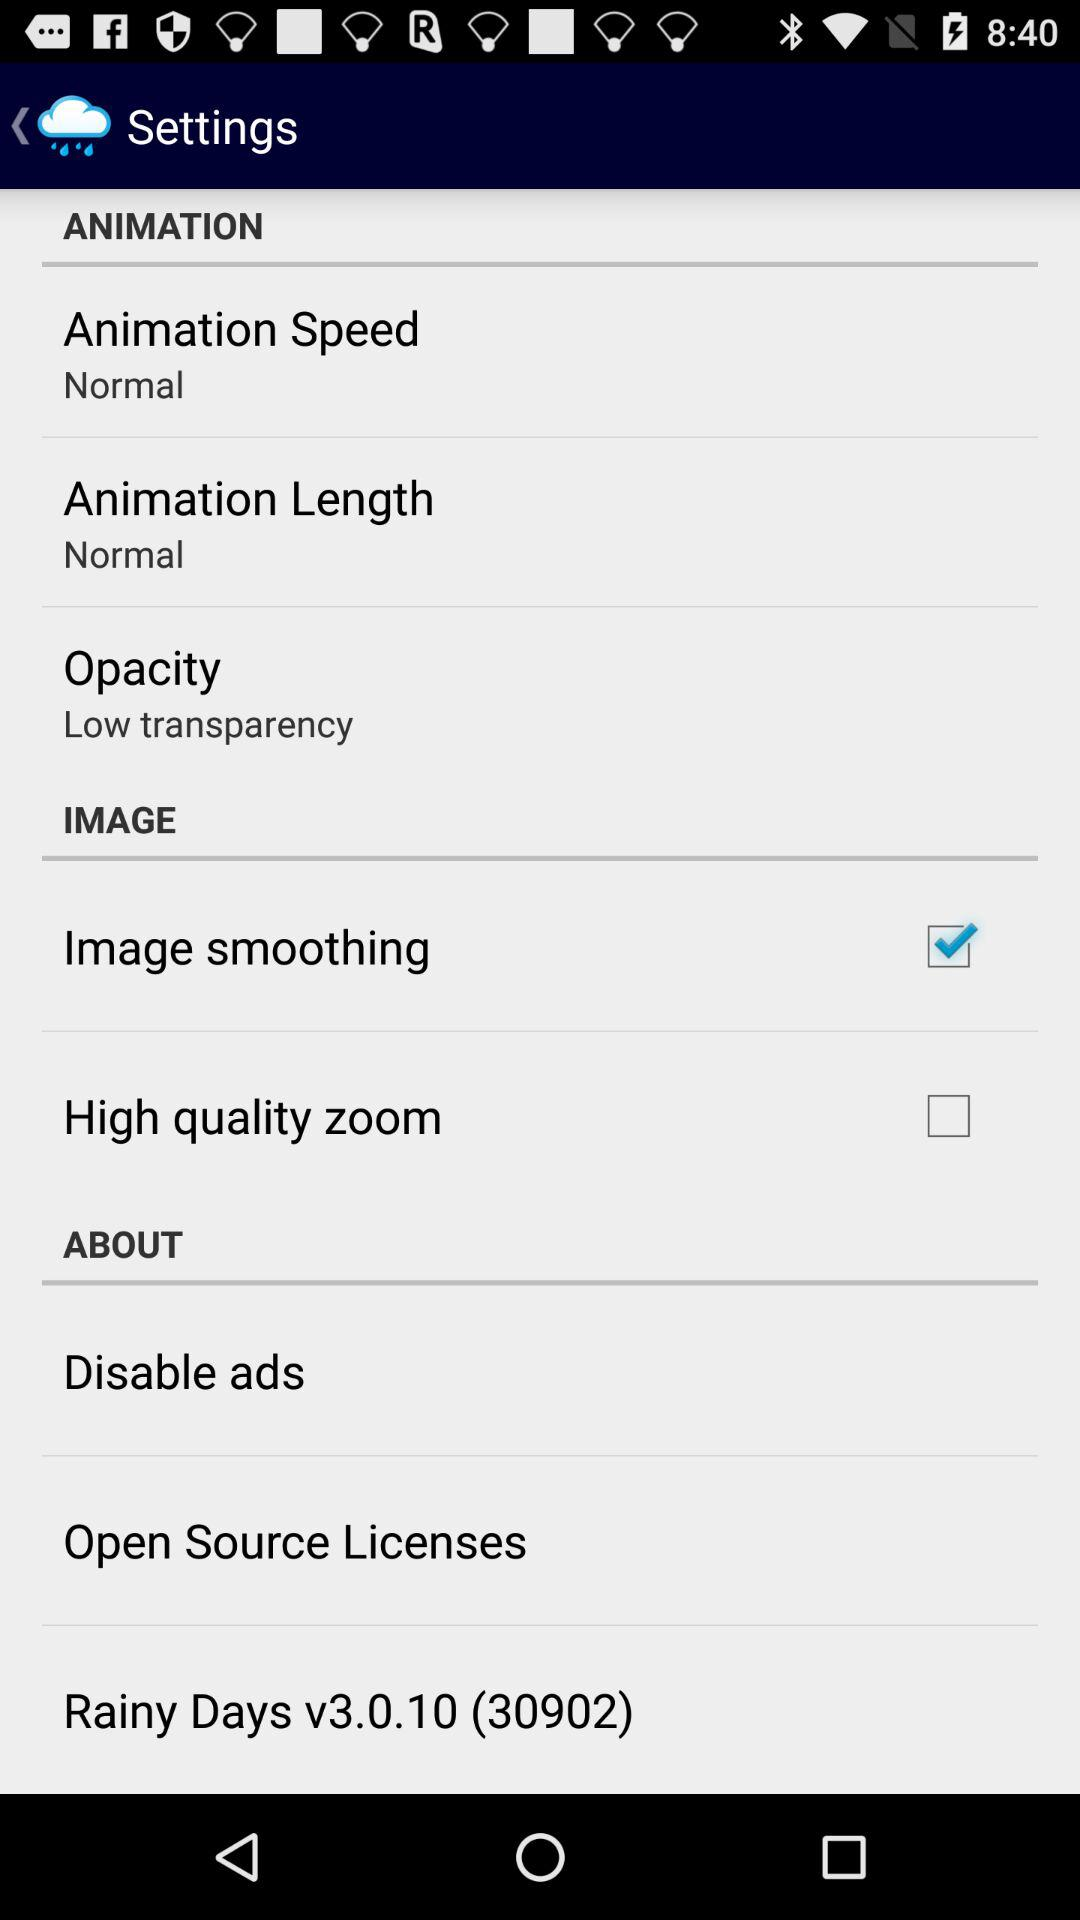Which option is checked? The checked option is "Image smoothing". 